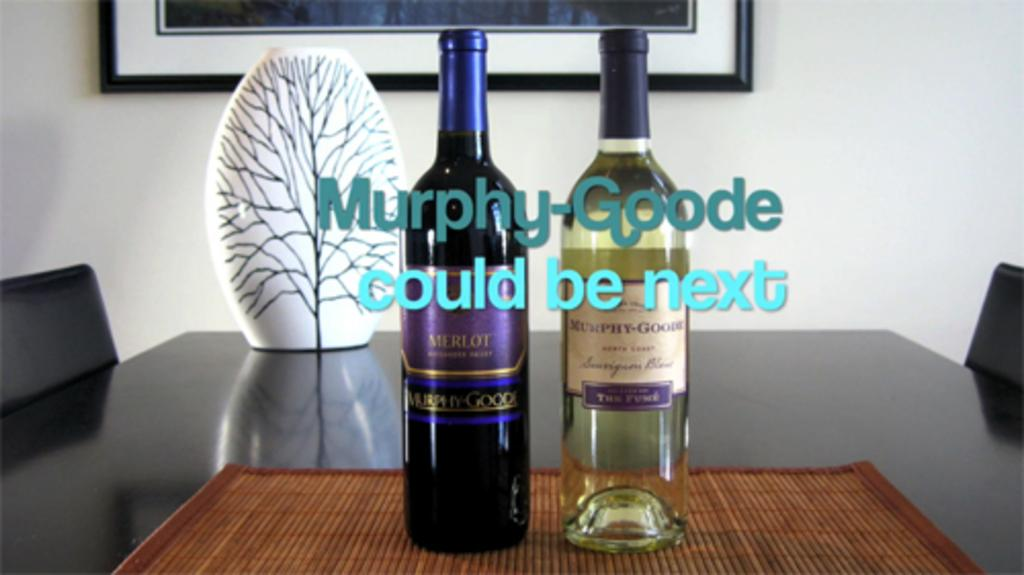<image>
Offer a succinct explanation of the picture presented. Two wine bottles, one merlot and one white with Murphy-Goode could be next overlaid text. 